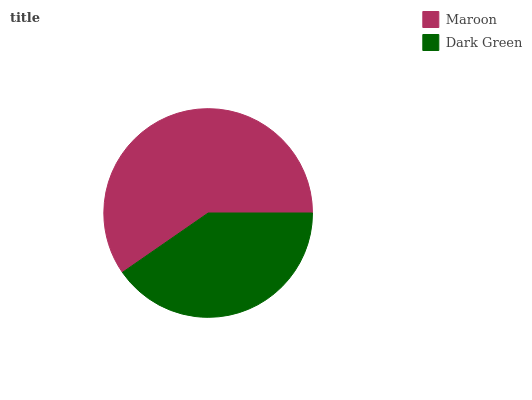Is Dark Green the minimum?
Answer yes or no. Yes. Is Maroon the maximum?
Answer yes or no. Yes. Is Dark Green the maximum?
Answer yes or no. No. Is Maroon greater than Dark Green?
Answer yes or no. Yes. Is Dark Green less than Maroon?
Answer yes or no. Yes. Is Dark Green greater than Maroon?
Answer yes or no. No. Is Maroon less than Dark Green?
Answer yes or no. No. Is Maroon the high median?
Answer yes or no. Yes. Is Dark Green the low median?
Answer yes or no. Yes. Is Dark Green the high median?
Answer yes or no. No. Is Maroon the low median?
Answer yes or no. No. 